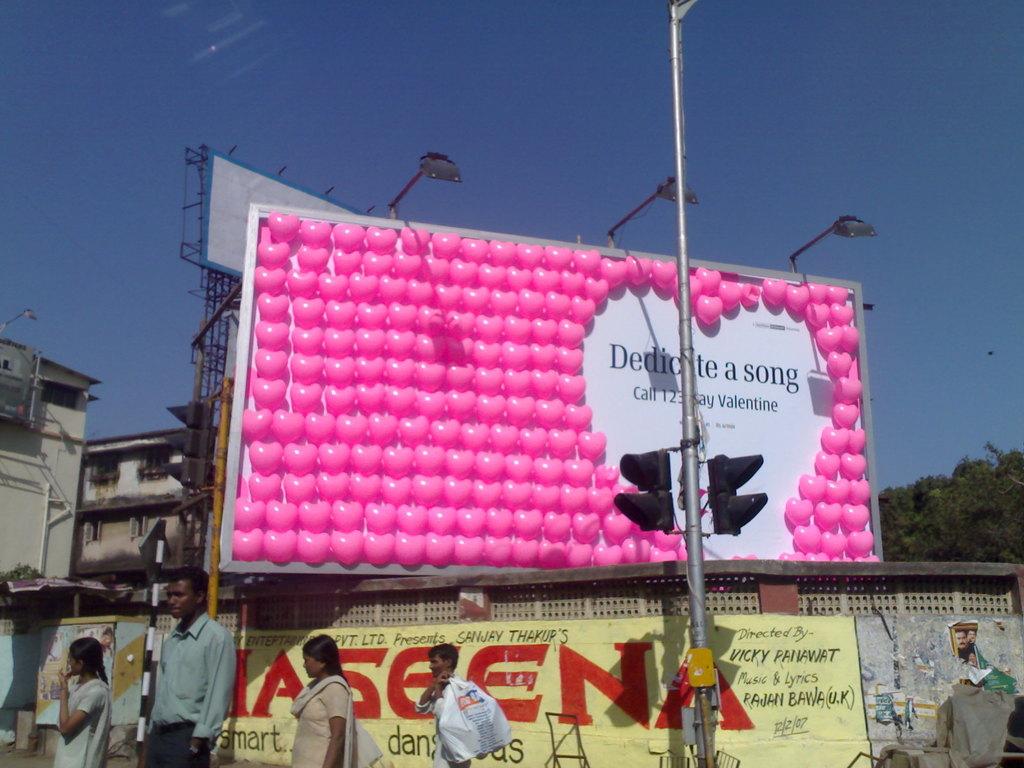When can you dedicate a song?
Offer a very short reply. Valentine. 